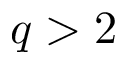Convert formula to latex. <formula><loc_0><loc_0><loc_500><loc_500>q > 2</formula> 